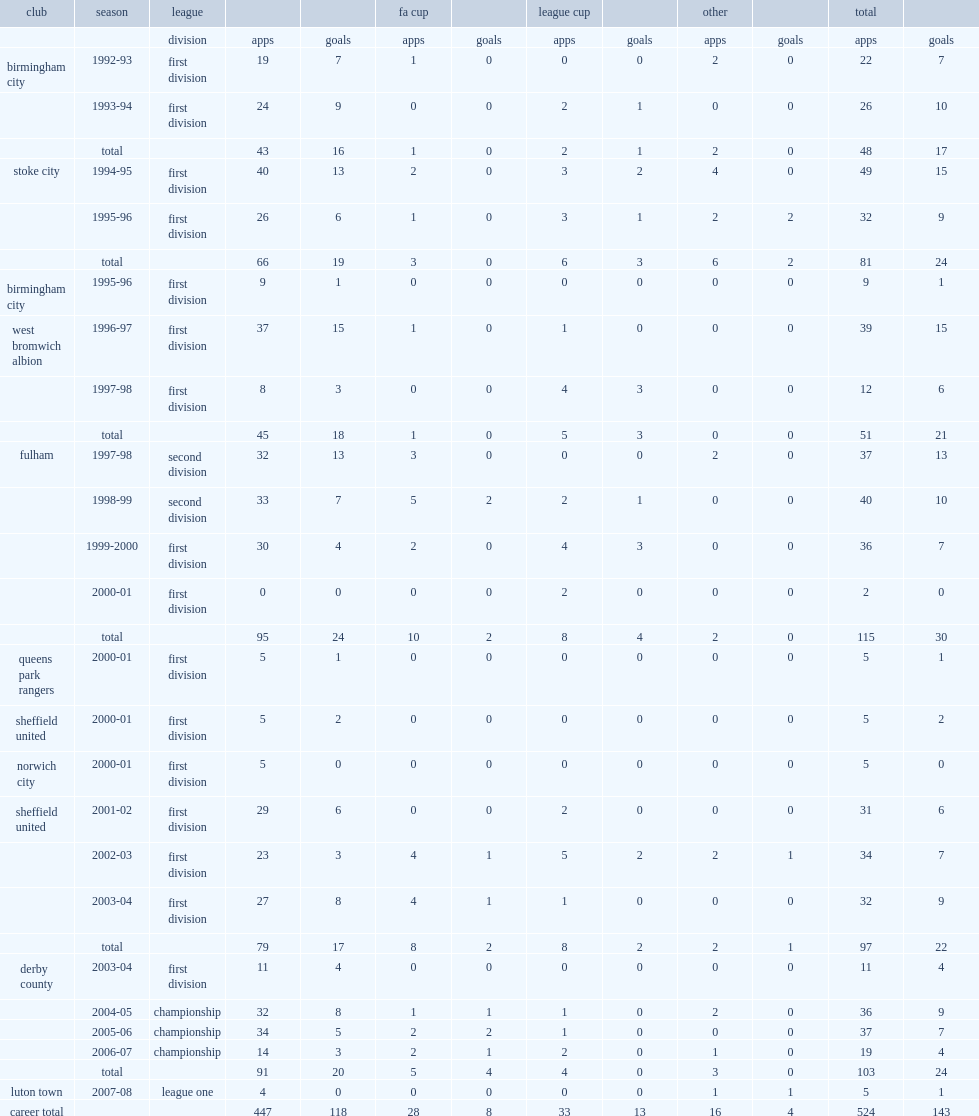How many league appearances had paul peschisolido accumulated over 16 years? 447. How many goals had paul peschisolido accumulated over 16 years? 118. 